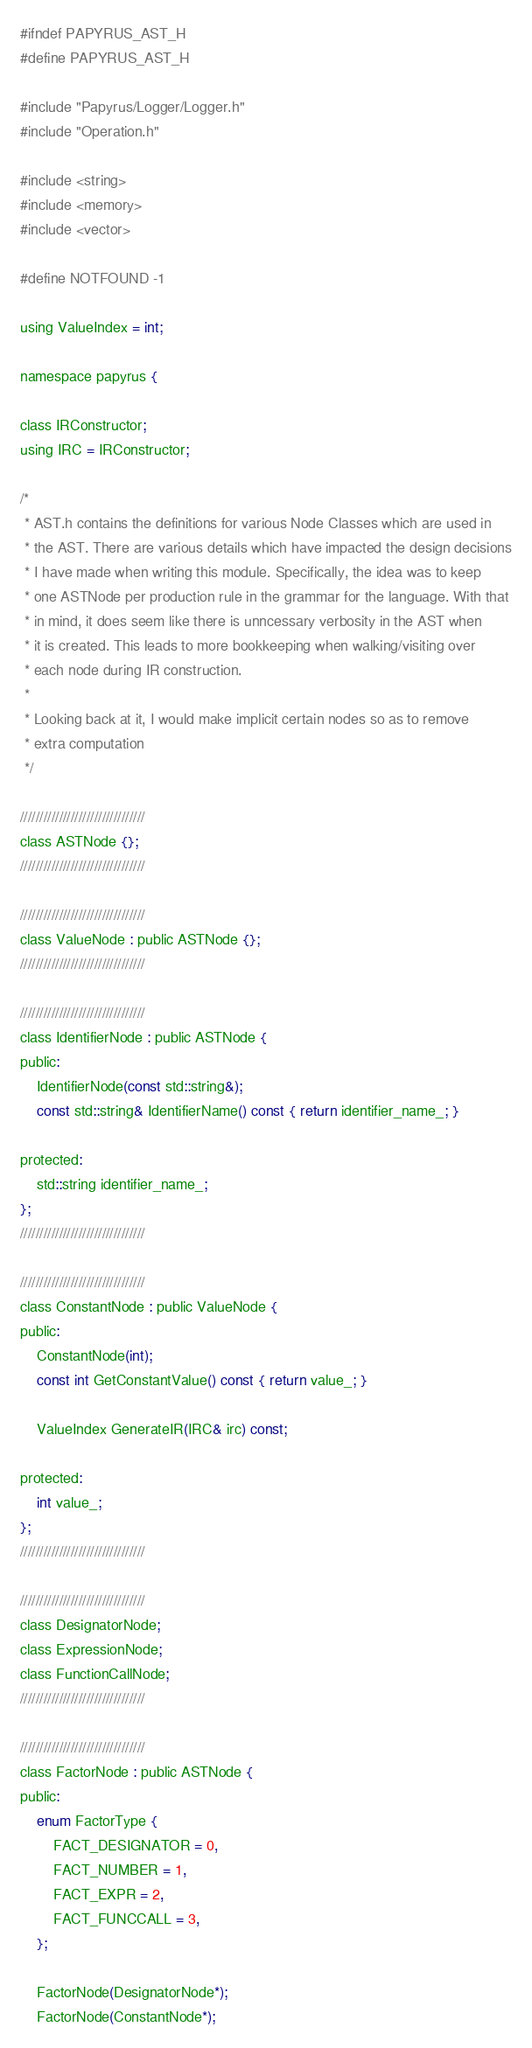Convert code to text. <code><loc_0><loc_0><loc_500><loc_500><_C_>#ifndef PAPYRUS_AST_H
#define PAPYRUS_AST_H

#include "Papyrus/Logger/Logger.h"
#include "Operation.h"

#include <string>
#include <memory>
#include <vector>

#define NOTFOUND -1

using ValueIndex = int;

namespace papyrus {

class IRConstructor;
using IRC = IRConstructor;

/*
 * AST.h contains the definitions for various Node Classes which are used in
 * the AST. There are various details which have impacted the design decisions
 * I have made when writing this module. Specifically, the idea was to keep
 * one ASTNode per production rule in the grammar for the language. With that
 * in mind, it does seem like there is unncessary verbosity in the AST when
 * it is created. This leads to more bookkeeping when walking/visiting over
 * each node during IR construction.
 *
 * Looking back at it, I would make implicit certain nodes so as to remove 
 * extra computation
 */

////////////////////////////////
class ASTNode {};
////////////////////////////////

////////////////////////////////
class ValueNode : public ASTNode {};
////////////////////////////////

////////////////////////////////
class IdentifierNode : public ASTNode {
public:
    IdentifierNode(const std::string&);
    const std::string& IdentifierName() const { return identifier_name_; }

protected:
    std::string identifier_name_;
};
////////////////////////////////

////////////////////////////////
class ConstantNode : public ValueNode {
public:
    ConstantNode(int);
    const int GetConstantValue() const { return value_; }

    ValueIndex GenerateIR(IRC& irc) const;

protected:
    int value_;
};
////////////////////////////////

////////////////////////////////
class DesignatorNode;
class ExpressionNode;
class FunctionCallNode;
////////////////////////////////

////////////////////////////////
class FactorNode : public ASTNode {
public:
    enum FactorType {
        FACT_DESIGNATOR = 0,
        FACT_NUMBER = 1,
        FACT_EXPR = 2,
        FACT_FUNCCALL = 3,
    };

    FactorNode(DesignatorNode*);
    FactorNode(ConstantNode*);</code> 